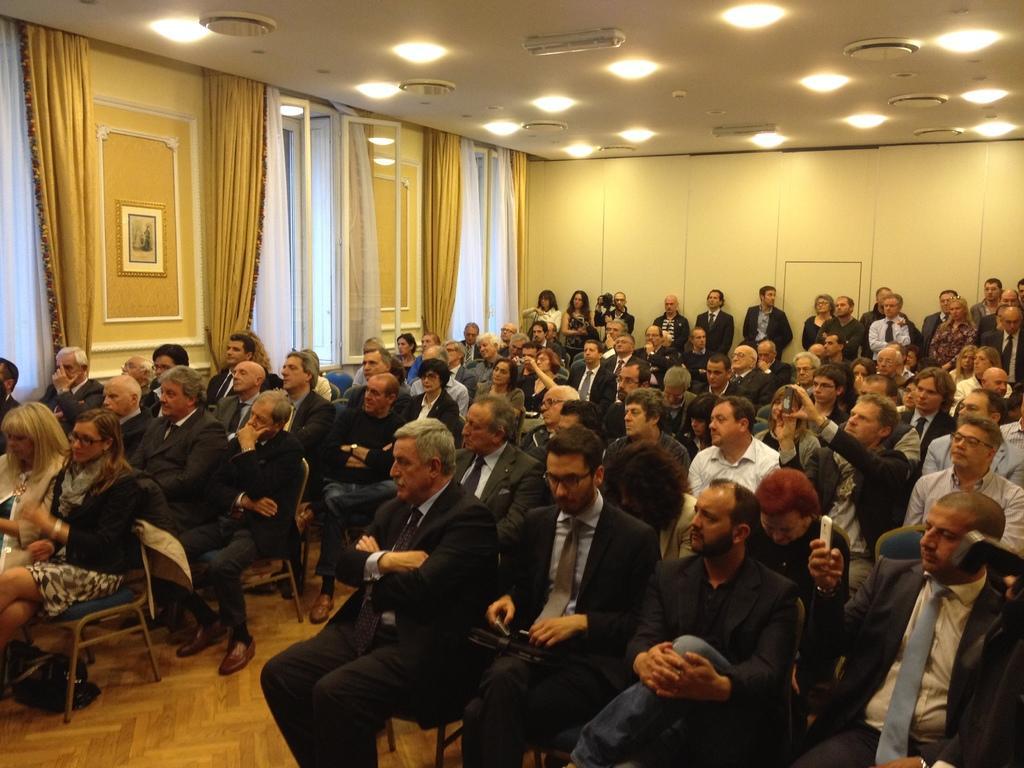Describe this image in one or two sentences. In this picture we can see a group of people sitting on chairs and some are standing on the floor and in the background we can see windows with curtains, lights, wall. 